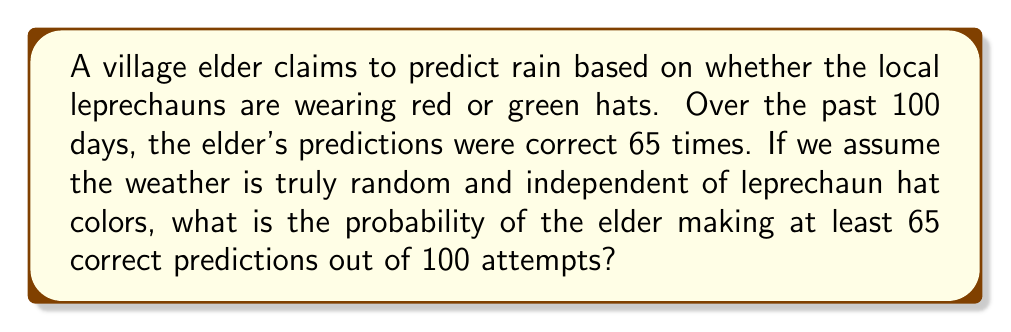Solve this math problem. Let's approach this step-by-step:

1) This is a binomial probability problem. We need to find $P(X \geq 65)$ where $X$ is the number of correct predictions.

2) If the weather is truly random and independent of the prediction method, the probability of a correct prediction on any given day is 0.5 (50% chance).

3) We can use the binomial distribution formula:

   $$P(X = k) = \binom{n}{k} p^k (1-p)^{n-k}$$

   where $n = 100$, $p = 0.5$, and $k$ ranges from 65 to 100.

4) To find $P(X \geq 65)$, we need to sum $P(X = k)$ for all $k$ from 65 to 100:

   $$P(X \geq 65) = \sum_{k=65}^{100} \binom{100}{k} (0.5)^k (0.5)^{100-k}$$

5) This sum is computationally intensive, so we can use the normal approximation to the binomial distribution:

   Mean: $\mu = np = 100 * 0.5 = 50$
   Standard deviation: $\sigma = \sqrt{np(1-p)} = \sqrt{100 * 0.5 * 0.5} = 5$

6) We can standardize our value:

   $$z = \frac{64.5 - 50}{5} = 2.9$$

   (We use 64.5 as the continuity correction)

7) Using a standard normal table or calculator, we can find:

   $$P(Z > 2.9) \approx 0.00187$$

Therefore, the probability of making at least 65 correct predictions out of 100 attempts by chance is approximately 0.00187 or 0.187%.
Answer: 0.00187 